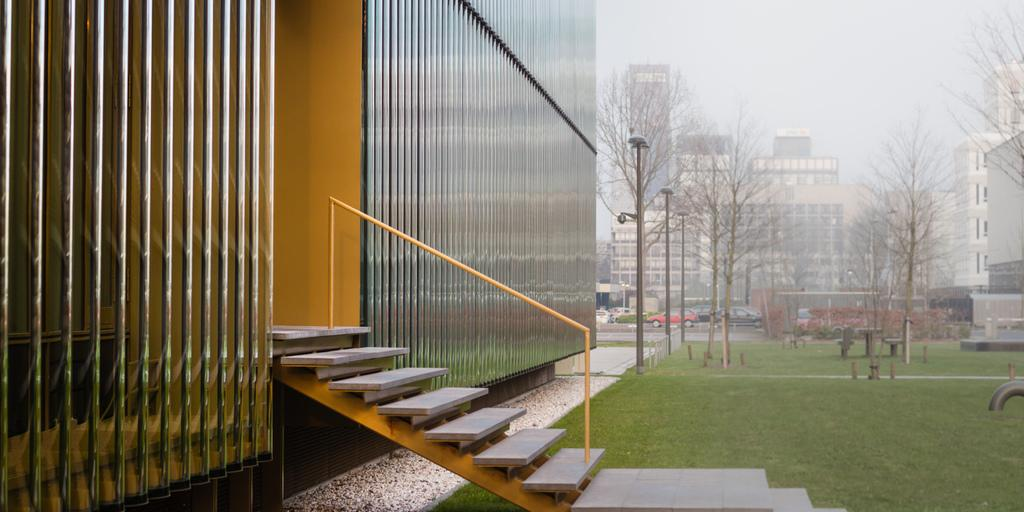What type of structure is present in the picture? There is a building in the picture. What architectural feature is visible in the picture? There are stairs and a railing in the picture. What type of natural environment is present in the picture? There is grass and trees in the picture. Are there any other structures visible in the picture? A: Yes, there are other buildings in the picture. What is the condition of the sky in the picture? The sky is clear in the picture. What is the rate of the question being asked in the image? There is no question being asked in the image, so it is not possible to determine a rate. What condition is the condition in when the image was taken? The provided facts do not mention any specific condition or situation related to the image, so it cannot be determined from the information given. 